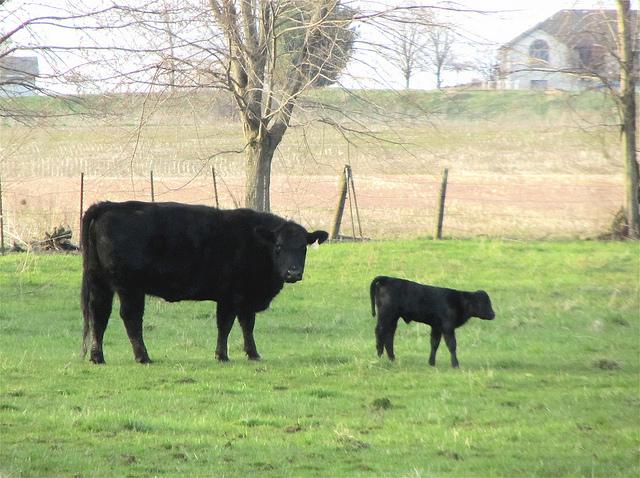What color are the cows?
Answer briefly. Black. How many cows are on the grass?
Give a very brief answer. 2. How many cows are facing the camera?
Write a very short answer. 1. Is this a meat-processing farm?
Answer briefly. No. How many adult cows are in the picture?
Give a very brief answer. 1. 